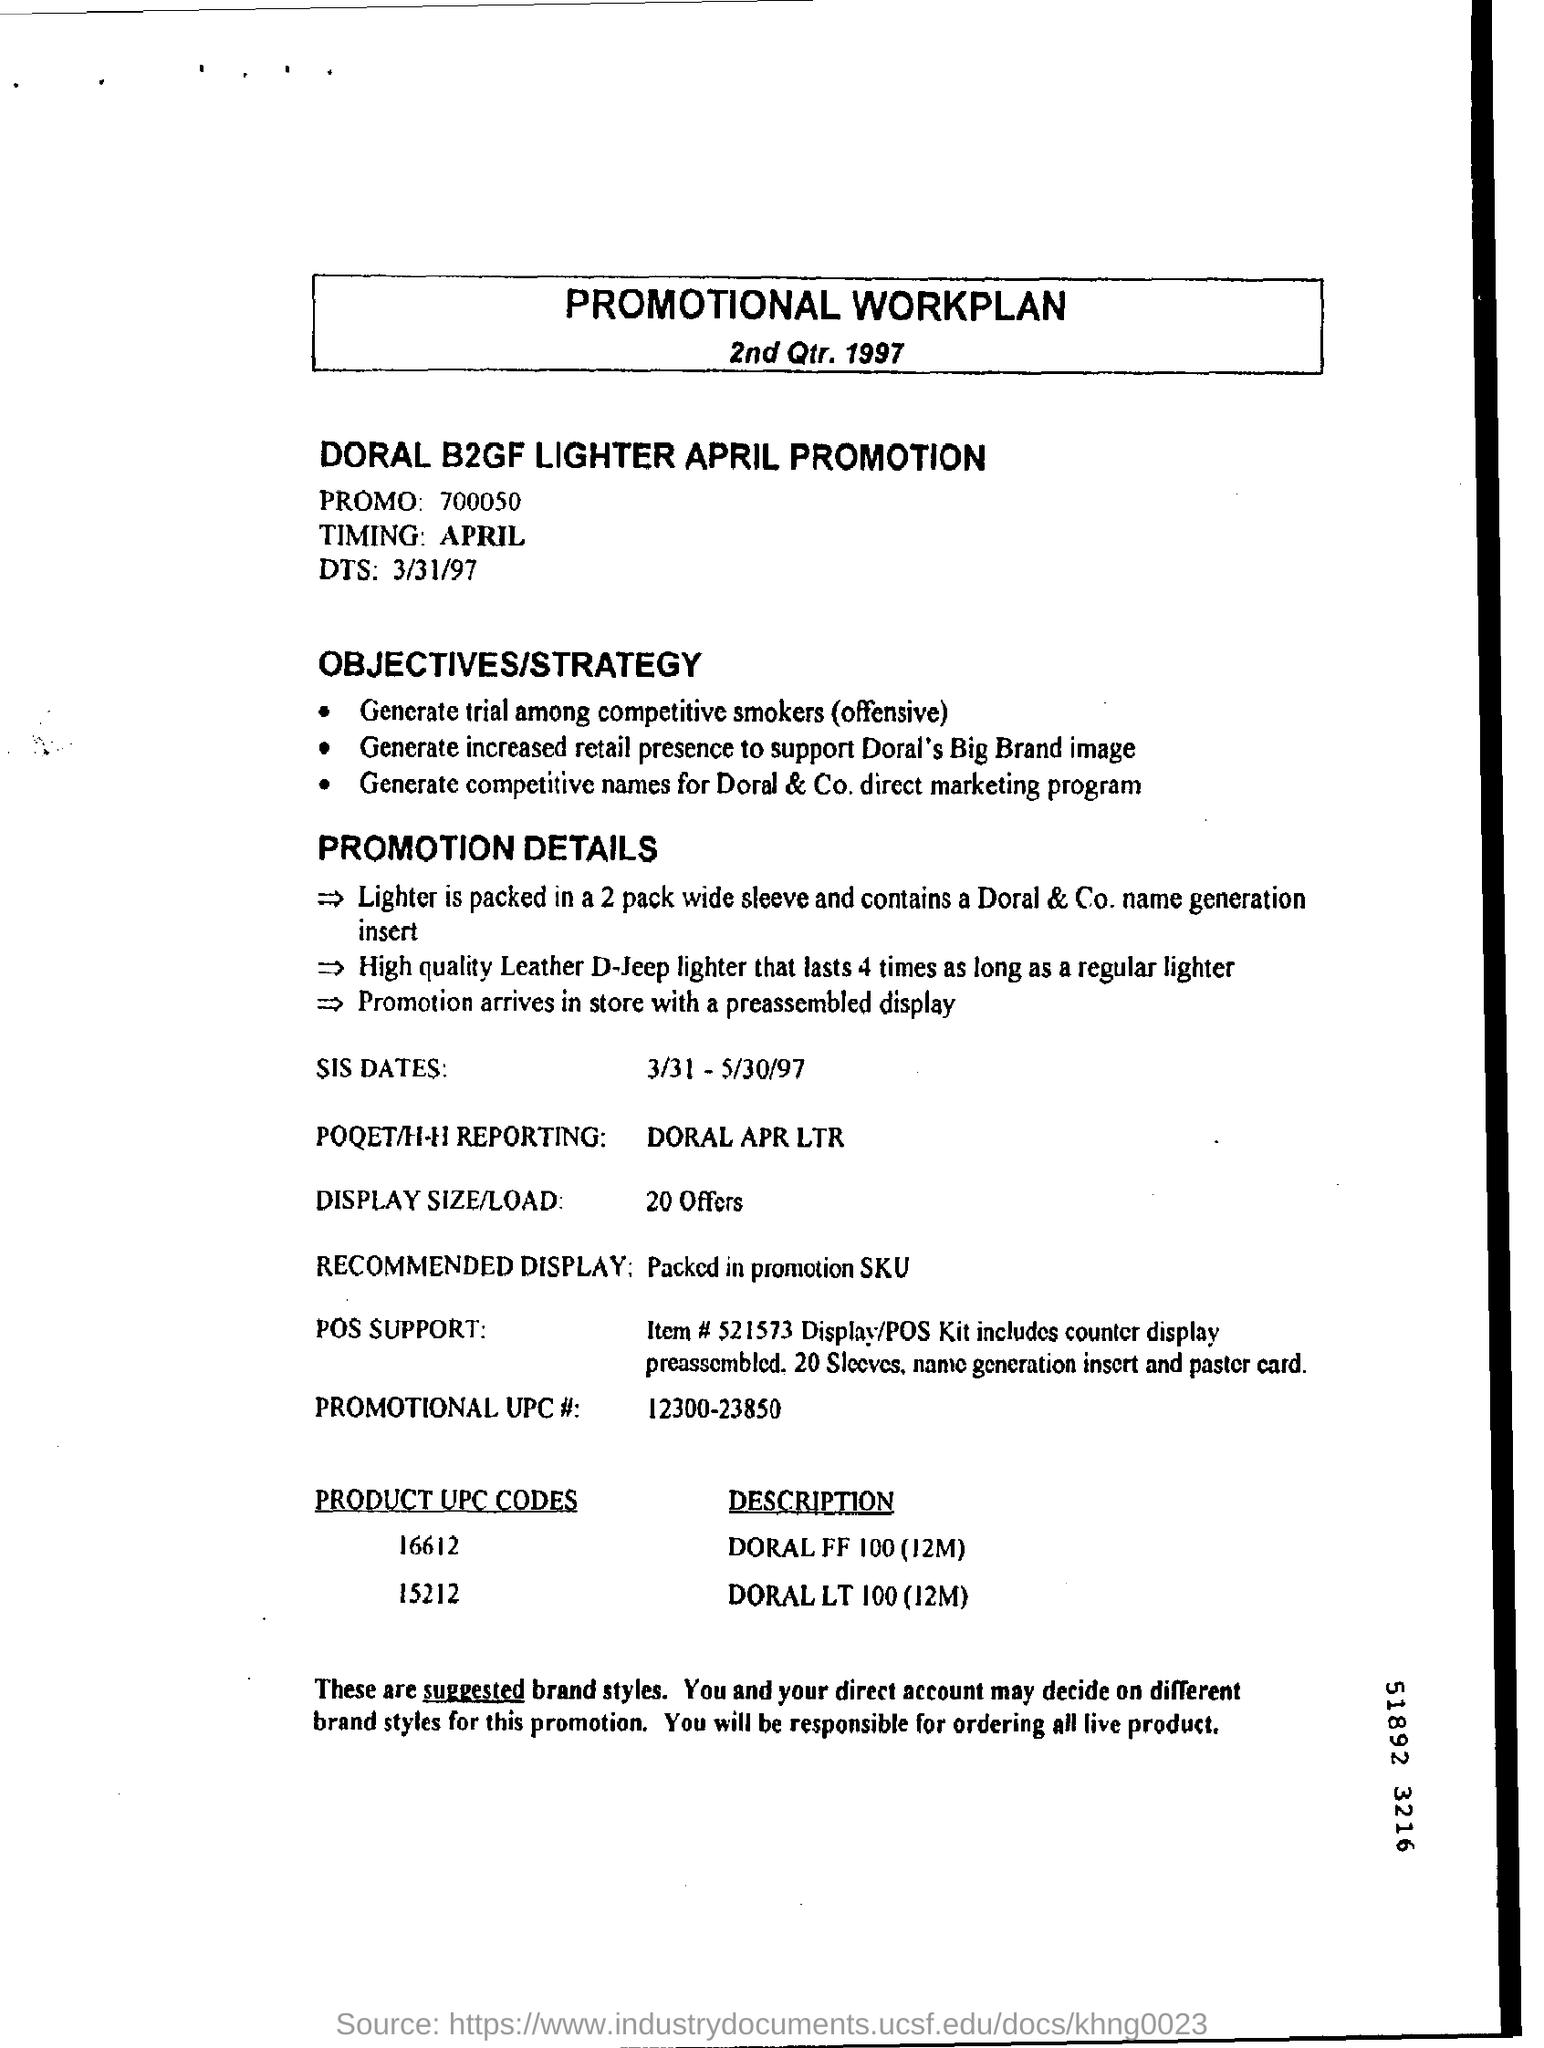Describe the support tools mentioned for this promotion? The support tools for this promotion include a POS Kit, which contains a counter display preassembled for convenience. Other tools featured are 20 sleeves, a 'name generation' insert, and a poster card, enhancing product visibility and consumer appeal. 